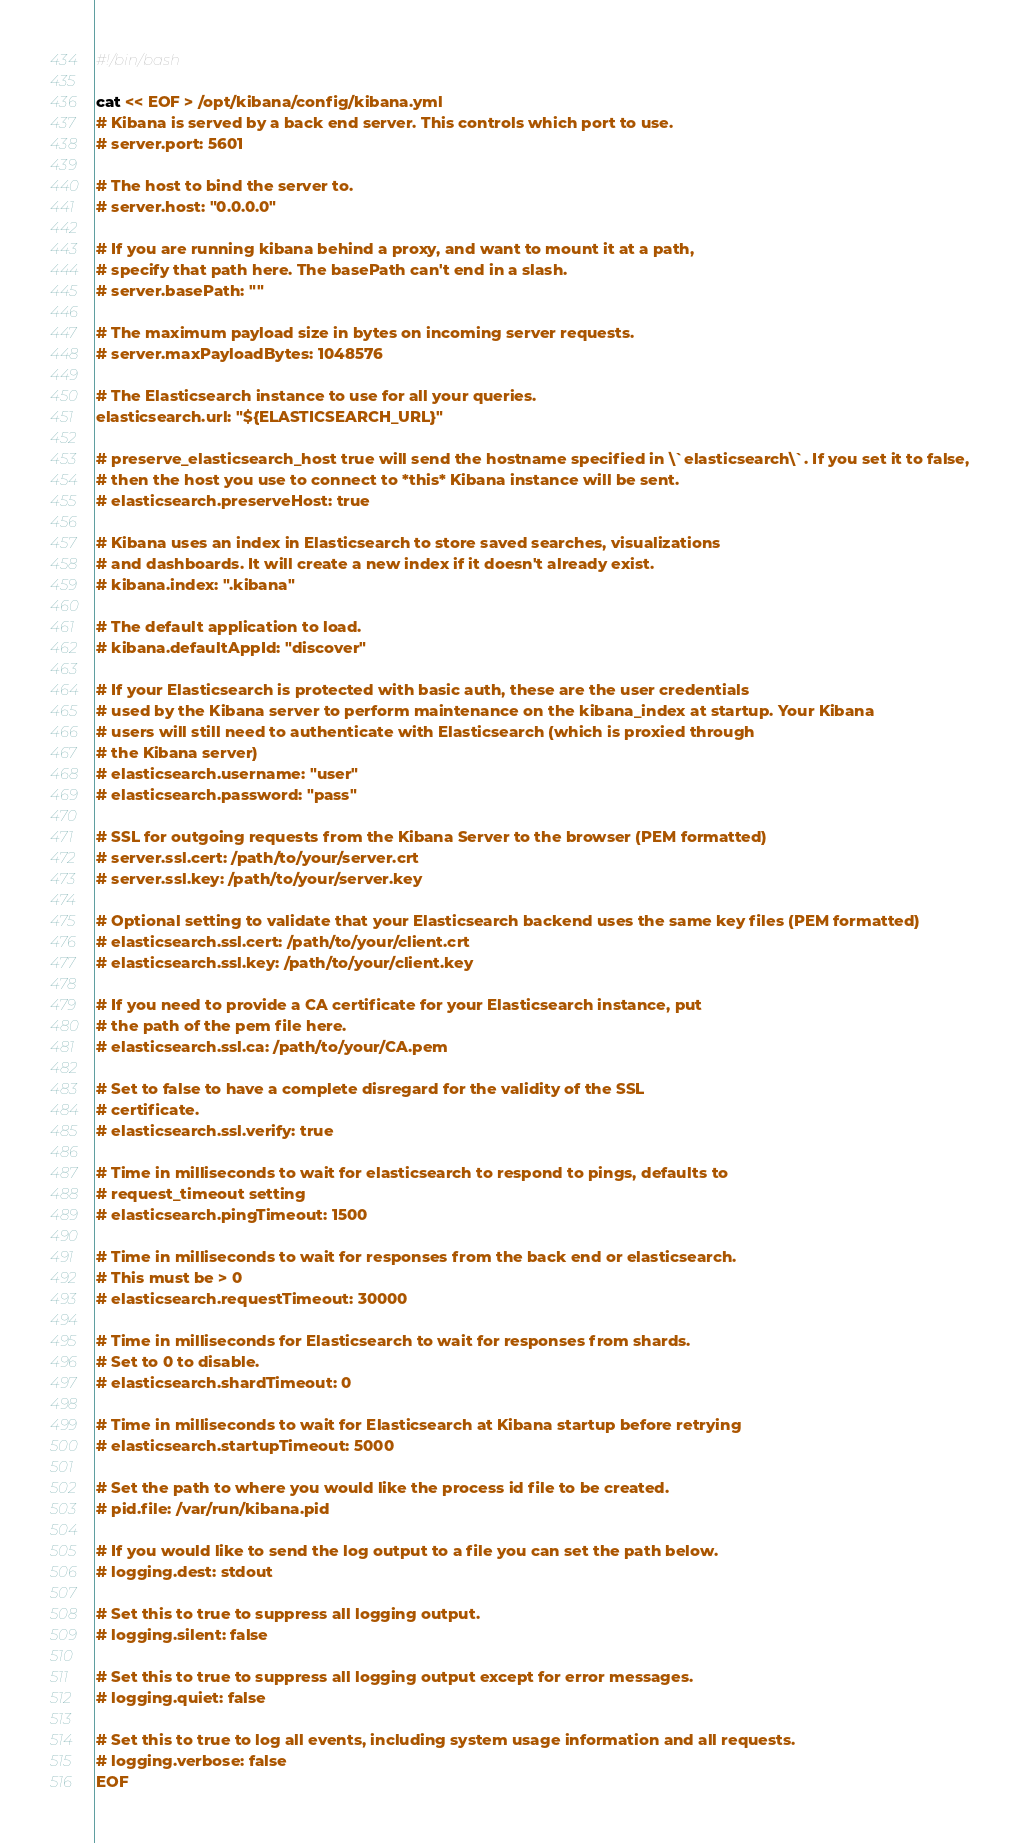<code> <loc_0><loc_0><loc_500><loc_500><_Bash_>#!/bin/bash

cat << EOF > /opt/kibana/config/kibana.yml
# Kibana is served by a back end server. This controls which port to use.
# server.port: 5601

# The host to bind the server to.
# server.host: "0.0.0.0"

# If you are running kibana behind a proxy, and want to mount it at a path,
# specify that path here. The basePath can't end in a slash.
# server.basePath: ""

# The maximum payload size in bytes on incoming server requests.
# server.maxPayloadBytes: 1048576

# The Elasticsearch instance to use for all your queries.
elasticsearch.url: "${ELASTICSEARCH_URL}"

# preserve_elasticsearch_host true will send the hostname specified in \`elasticsearch\`. If you set it to false,
# then the host you use to connect to *this* Kibana instance will be sent.
# elasticsearch.preserveHost: true

# Kibana uses an index in Elasticsearch to store saved searches, visualizations
# and dashboards. It will create a new index if it doesn't already exist.
# kibana.index: ".kibana"

# The default application to load.
# kibana.defaultAppId: "discover"

# If your Elasticsearch is protected with basic auth, these are the user credentials
# used by the Kibana server to perform maintenance on the kibana_index at startup. Your Kibana
# users will still need to authenticate with Elasticsearch (which is proxied through
# the Kibana server)
# elasticsearch.username: "user"
# elasticsearch.password: "pass"

# SSL for outgoing requests from the Kibana Server to the browser (PEM formatted)
# server.ssl.cert: /path/to/your/server.crt
# server.ssl.key: /path/to/your/server.key

# Optional setting to validate that your Elasticsearch backend uses the same key files (PEM formatted)
# elasticsearch.ssl.cert: /path/to/your/client.crt
# elasticsearch.ssl.key: /path/to/your/client.key

# If you need to provide a CA certificate for your Elasticsearch instance, put
# the path of the pem file here.
# elasticsearch.ssl.ca: /path/to/your/CA.pem

# Set to false to have a complete disregard for the validity of the SSL
# certificate.
# elasticsearch.ssl.verify: true

# Time in milliseconds to wait for elasticsearch to respond to pings, defaults to
# request_timeout setting
# elasticsearch.pingTimeout: 1500

# Time in milliseconds to wait for responses from the back end or elasticsearch.
# This must be > 0
# elasticsearch.requestTimeout: 30000

# Time in milliseconds for Elasticsearch to wait for responses from shards.
# Set to 0 to disable.
# elasticsearch.shardTimeout: 0

# Time in milliseconds to wait for Elasticsearch at Kibana startup before retrying
# elasticsearch.startupTimeout: 5000

# Set the path to where you would like the process id file to be created.
# pid.file: /var/run/kibana.pid

# If you would like to send the log output to a file you can set the path below.
# logging.dest: stdout

# Set this to true to suppress all logging output.
# logging.silent: false

# Set this to true to suppress all logging output except for error messages.
# logging.quiet: false

# Set this to true to log all events, including system usage information and all requests.
# logging.verbose: false
EOF
</code> 